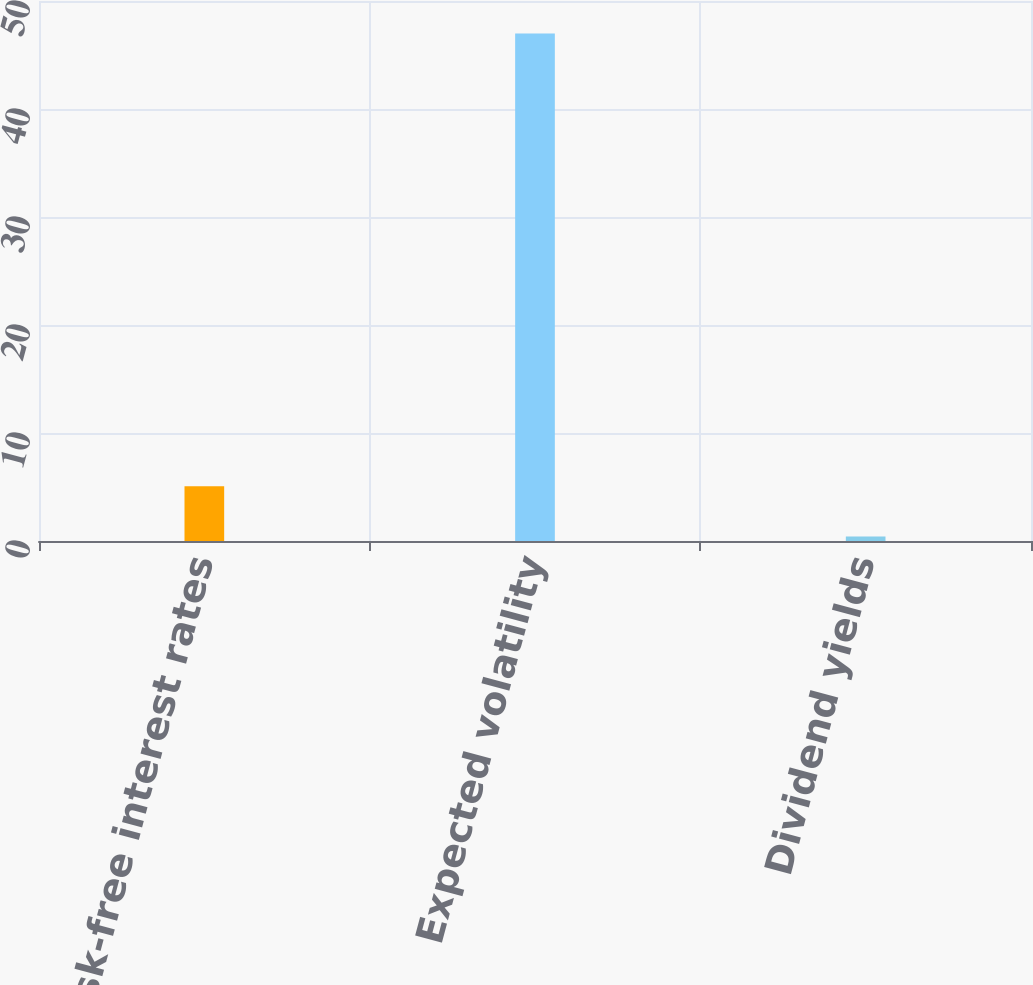<chart> <loc_0><loc_0><loc_500><loc_500><bar_chart><fcel>Risk-free interest rates<fcel>Expected volatility<fcel>Dividend yields<nl><fcel>5.07<fcel>47<fcel>0.41<nl></chart> 